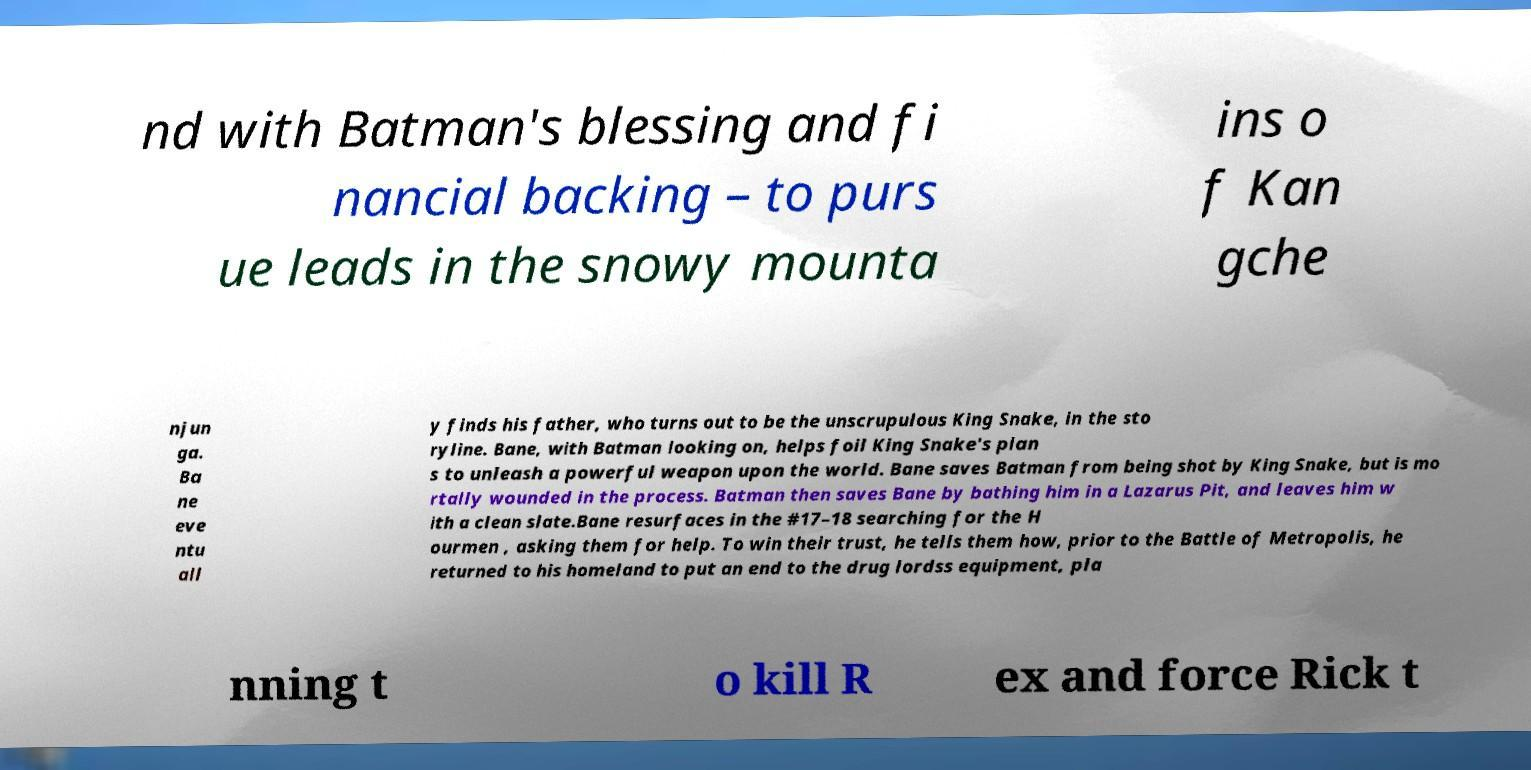Can you accurately transcribe the text from the provided image for me? nd with Batman's blessing and fi nancial backing – to purs ue leads in the snowy mounta ins o f Kan gche njun ga. Ba ne eve ntu all y finds his father, who turns out to be the unscrupulous King Snake, in the sto ryline. Bane, with Batman looking on, helps foil King Snake's plan s to unleash a powerful weapon upon the world. Bane saves Batman from being shot by King Snake, but is mo rtally wounded in the process. Batman then saves Bane by bathing him in a Lazarus Pit, and leaves him w ith a clean slate.Bane resurfaces in the #17–18 searching for the H ourmen , asking them for help. To win their trust, he tells them how, prior to the Battle of Metropolis, he returned to his homeland to put an end to the drug lordss equipment, pla nning t o kill R ex and force Rick t 